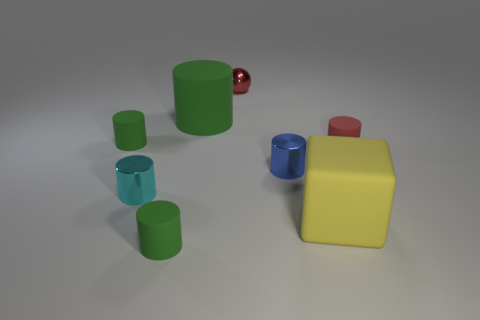What is the color of the large cylinder?
Your answer should be very brief. Green. There is a tiny red object that is made of the same material as the yellow block; what is its shape?
Provide a short and direct response. Cylinder. There is a metal thing that is left of the red shiny object; is it the same size as the ball?
Offer a terse response. Yes. How many things are red shiny spheres that are behind the large green thing or rubber things to the left of the blue metallic cylinder?
Your answer should be compact. 4. There is a tiny cylinder that is behind the red matte object; is its color the same as the tiny shiny ball?
Your response must be concise. No. What number of metal objects are either big yellow things or large gray things?
Provide a short and direct response. 0. The red matte object has what shape?
Your answer should be compact. Cylinder. Is there any other thing that has the same material as the tiny red sphere?
Offer a terse response. Yes. Are the small cyan object and the block made of the same material?
Give a very brief answer. No. There is a red rubber object right of the metallic cylinder on the right side of the red metal thing; is there a red shiny ball that is in front of it?
Your response must be concise. No. 